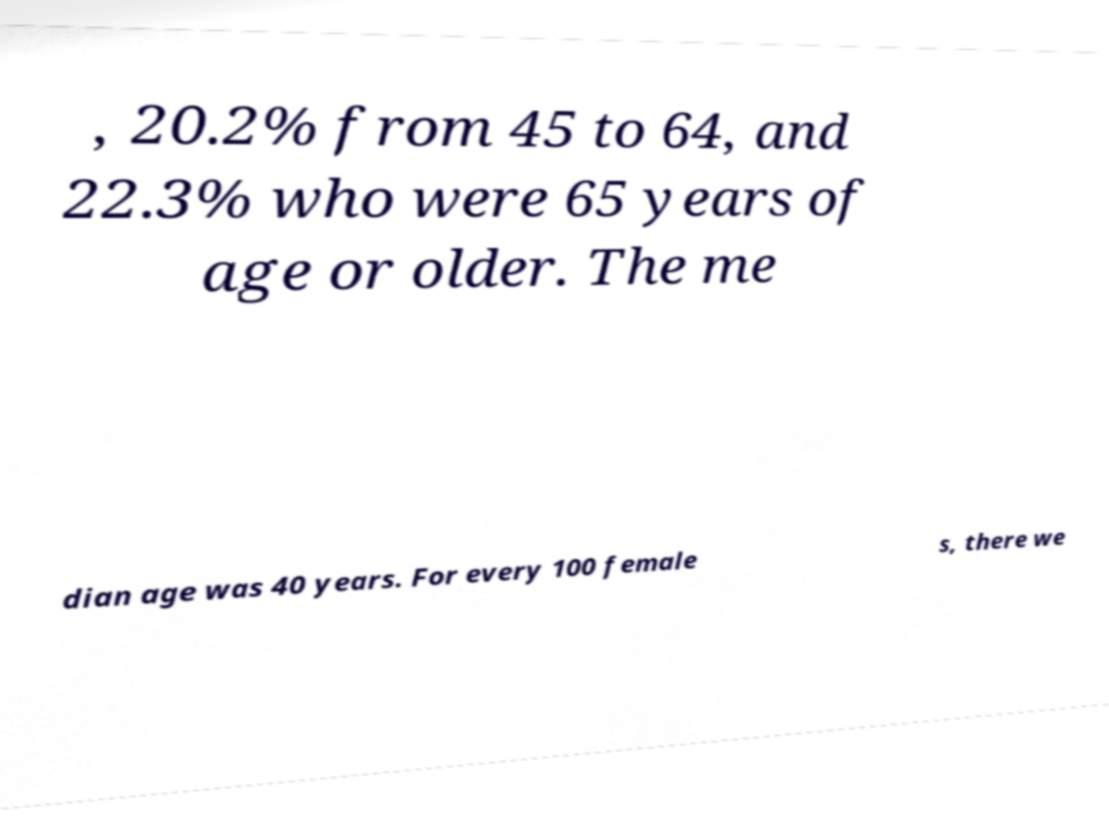Can you accurately transcribe the text from the provided image for me? , 20.2% from 45 to 64, and 22.3% who were 65 years of age or older. The me dian age was 40 years. For every 100 female s, there we 